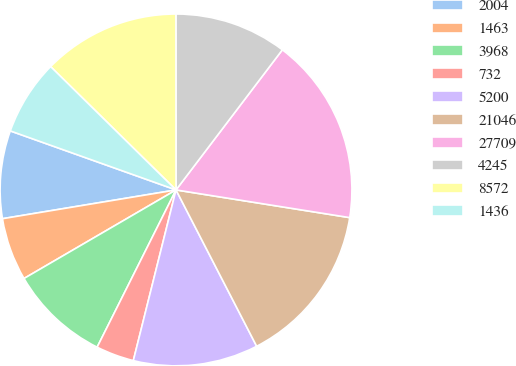Convert chart. <chart><loc_0><loc_0><loc_500><loc_500><pie_chart><fcel>2004<fcel>1463<fcel>3968<fcel>732<fcel>5200<fcel>21046<fcel>27709<fcel>4245<fcel>8572<fcel>1436<nl><fcel>8.06%<fcel>5.78%<fcel>9.2%<fcel>3.5%<fcel>11.48%<fcel>14.9%<fcel>17.18%<fcel>10.34%<fcel>12.62%<fcel>6.92%<nl></chart> 